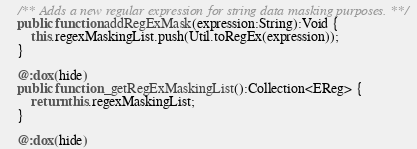Convert code to text. <code><loc_0><loc_0><loc_500><loc_500><_Haxe_>    /** Adds a new regular expression for string data masking purposes. **/
    public function addRegExMask(expression:String):Void {
        this.regexMaskingList.push(Util.toRegEx(expression));
    }

    @:dox(hide)
    public function _getRegExMaskingList():Collection<EReg> {
        return this.regexMaskingList;
    }

    @:dox(hide)</code> 